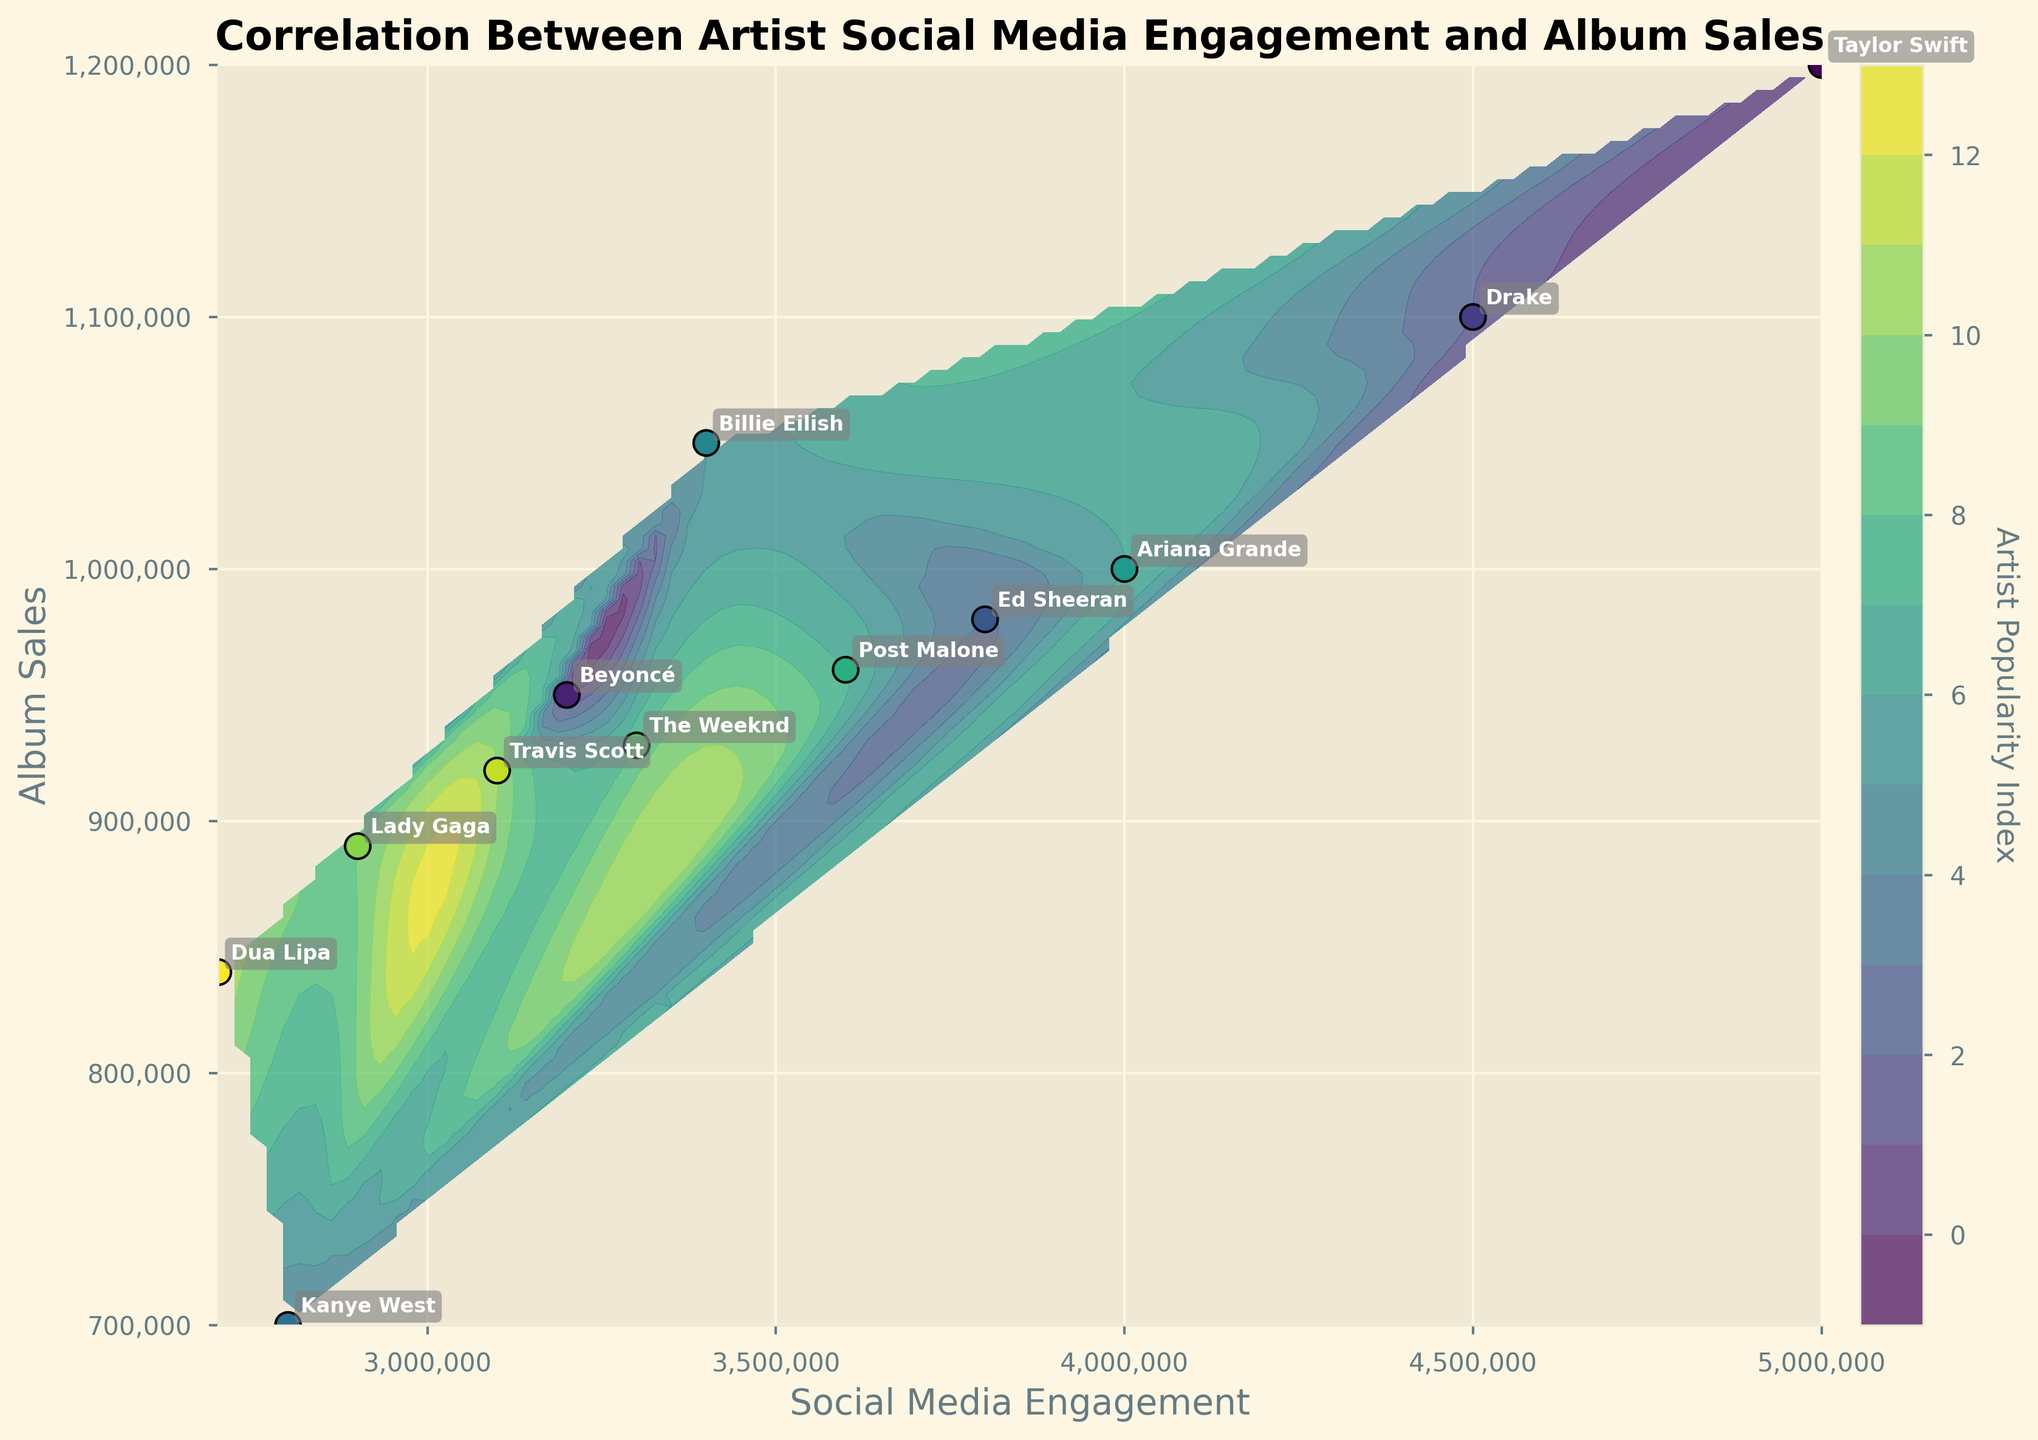How many artists are represented in the plot? Count the number of data points in the scatter plot, each representing an artist.
Answer: 12 What is the title of the plot? Look at the main title text displayed at the top of the plot.
Answer: Correlation Between Artist Social Media Engagement and Album Sales Which artist has the highest social media engagement? Identify the artist with the highest value on the x-axis (Social Media Engagement).
Answer: Taylor Swift What are the labels for the x-axis and y-axis? Check the text displayed next to the x-axis and y-axis of the plot.
Answer: Social Media Engagement (x-axis) and Album Sales (y-axis) Which artist has the lowest album sales? Identify the artist with the lowest value on the y-axis (Album Sales).
Answer: Kanye West What is the social media engagement of Beyoncé? Find the labeled point for Beyoncé and read its x-axis value.
Answer: 3,200,000 Who has higher album sales, Post Malone or Drake? Compare the y-axis values for Post Malone and Drake.
Answer: Drake What does the color bar represent in the plot? Look at the label next to the color bar.
Answer: Artist Popularity Index How do social media engagement and album sales trend together? Observe the overall pattern of data points and contours in the plot.
Answer: Positive correlation Which two artists have similar album sales but different social media engagement? Look for data points on the plot that have close y-axis values but different x-axis values, annotating the artists' names.
Answer: Lady Gaga and Travis Scott 